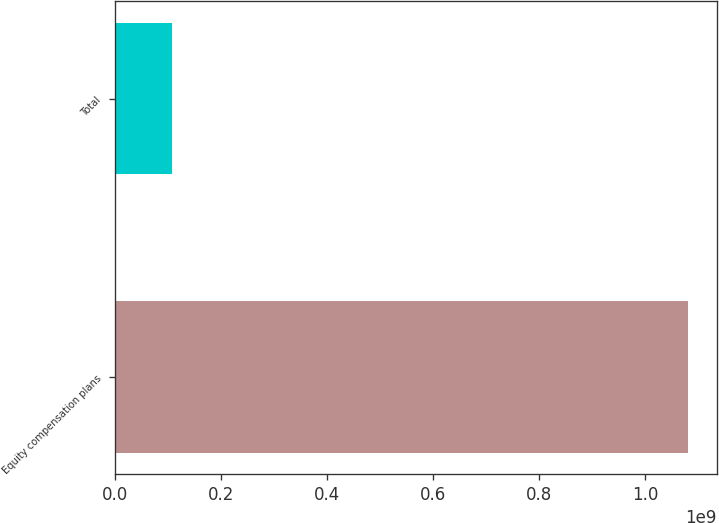Convert chart. <chart><loc_0><loc_0><loc_500><loc_500><bar_chart><fcel>Equity compensation plans<fcel>Total<nl><fcel>1.08067e+09<fcel>1.08067e+08<nl></chart> 